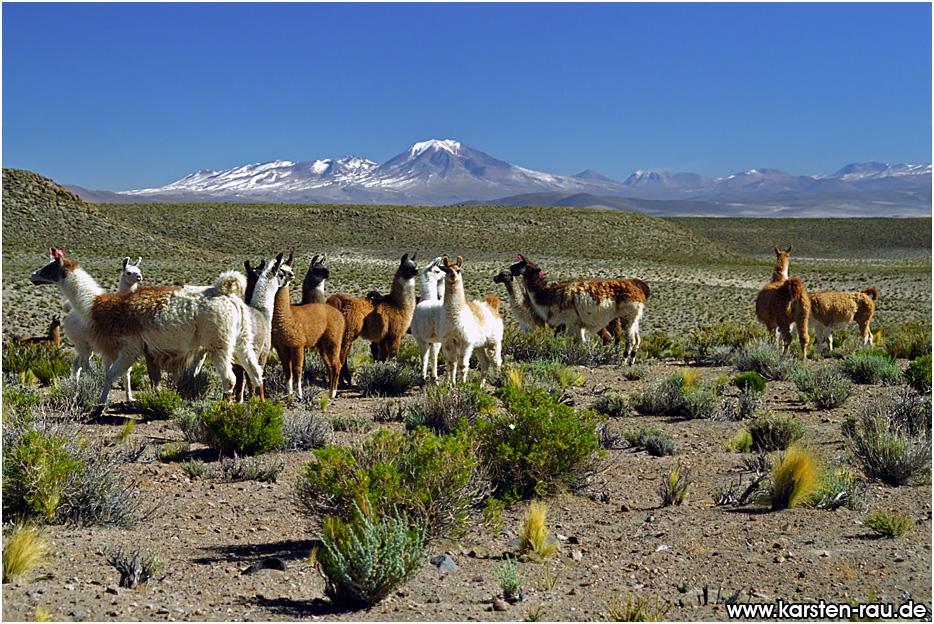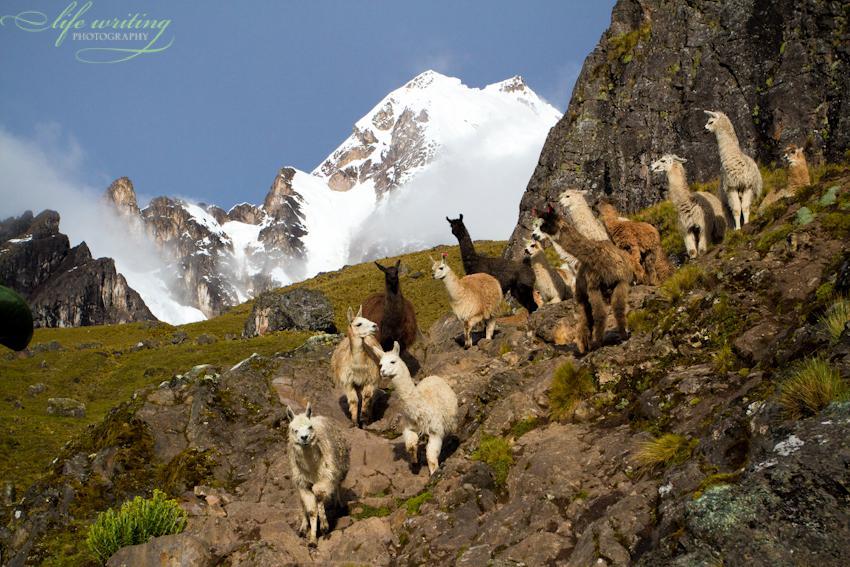The first image is the image on the left, the second image is the image on the right. For the images displayed, is the sentence "In the right image, fewer than ten llamas wander through grass scrubs, and a snow covered mountain is in the background." factually correct? Answer yes or no. No. The first image is the image on the left, the second image is the image on the right. Given the left and right images, does the statement "The right image shows a line of rightward facing llamas standing on ground with sparse foliage and mountain peaks in the background." hold true? Answer yes or no. No. 